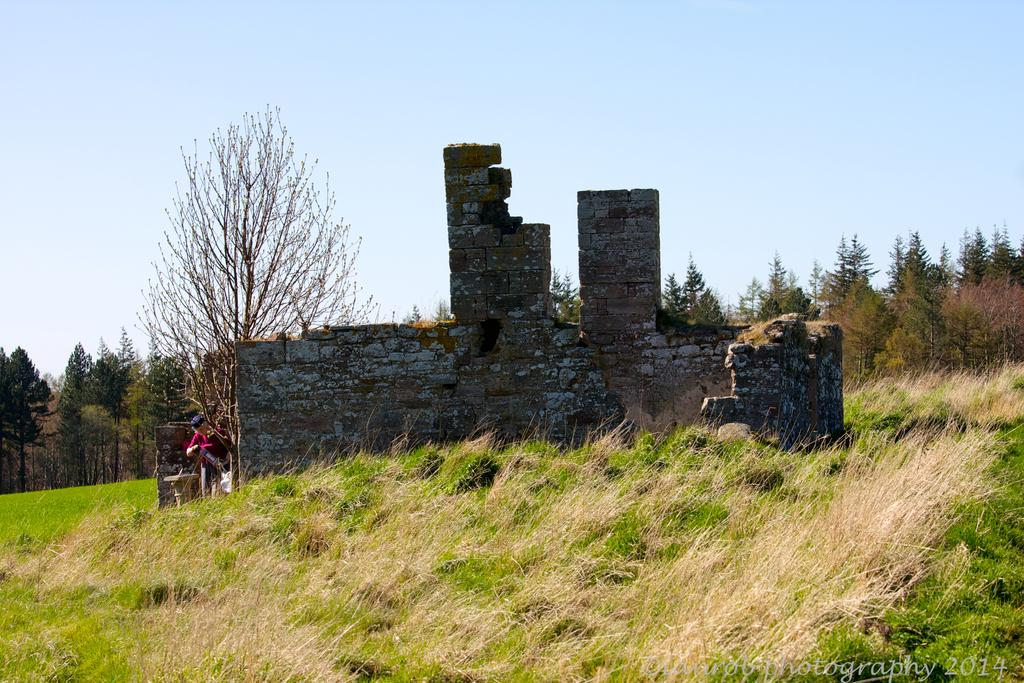Who or what is present in the image? There is a person in the image. Where is the person located in relation to other elements in the image? The person is beside a wall. What is the surface underfoot in the image? The floor is made of grass. What type of vegetation can be seen in the image? There are plants and trees in the image. What type of cord is being used by the person in the image? There is no cord visible in the image. 